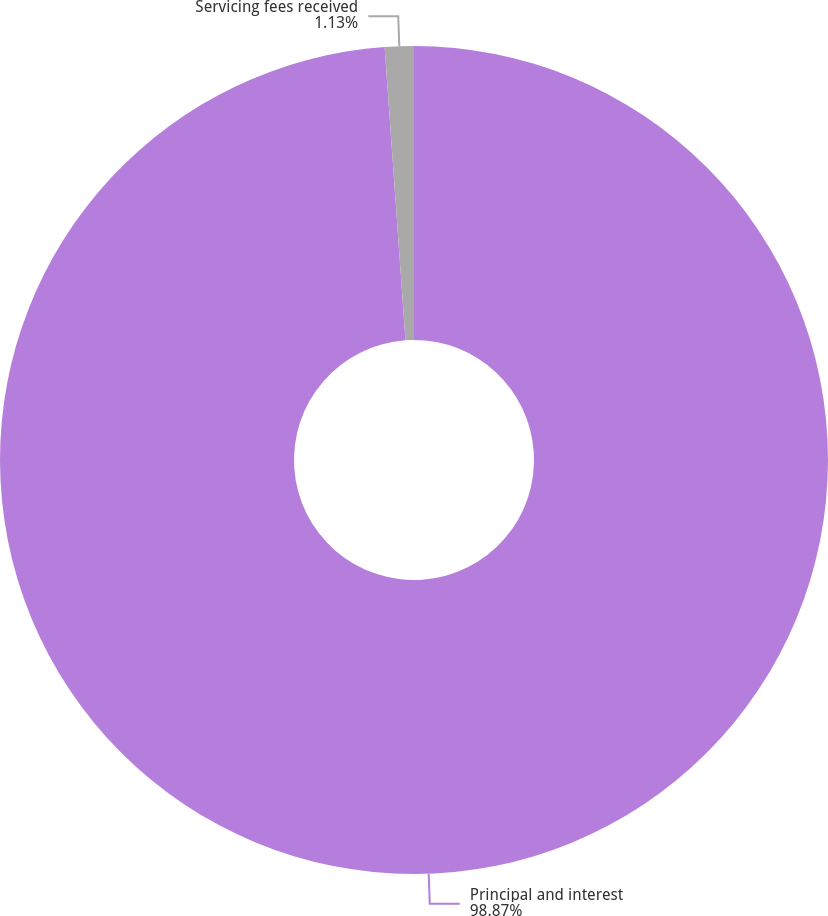Convert chart. <chart><loc_0><loc_0><loc_500><loc_500><pie_chart><fcel>Principal and interest<fcel>Servicing fees received<nl><fcel>98.87%<fcel>1.13%<nl></chart> 